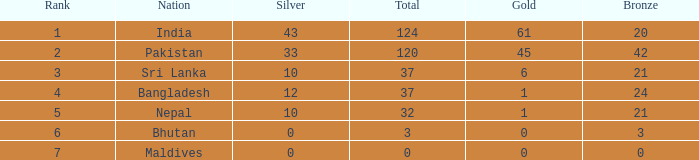What is the rank of a 21 bronze and a silver greater than 10? 0.0. 